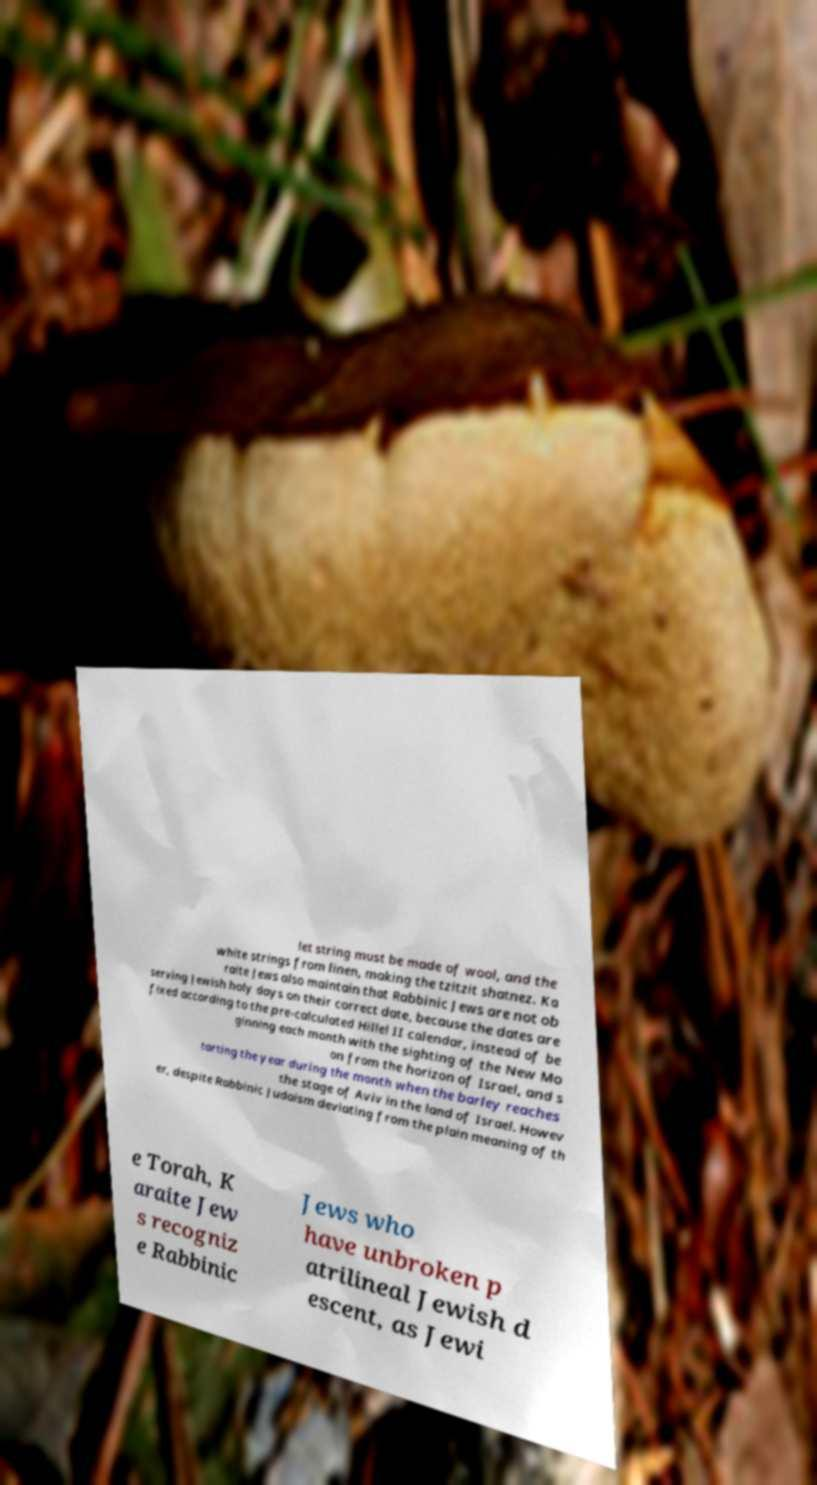I need the written content from this picture converted into text. Can you do that? let string must be made of wool, and the white strings from linen, making the tzitzit shatnez. Ka raite Jews also maintain that Rabbinic Jews are not ob serving Jewish holy days on their correct date, because the dates are fixed according to the pre-calculated Hillel II calendar, instead of be ginning each month with the sighting of the New Mo on from the horizon of Israel, and s tarting the year during the month when the barley reaches the stage of Aviv in the land of Israel. Howev er, despite Rabbinic Judaism deviating from the plain meaning of th e Torah, K araite Jew s recogniz e Rabbinic Jews who have unbroken p atrilineal Jewish d escent, as Jewi 